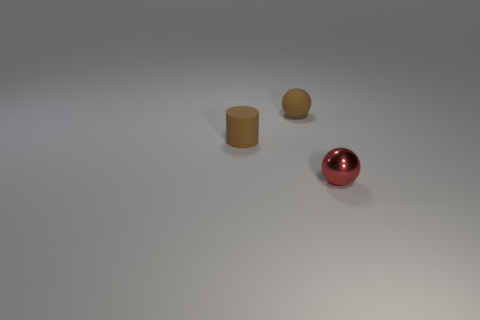Considering the surface in the image, what material might it be and can you describe the texture? The surface in the image appears to be a flat, horizontal plane with a smooth texture. The lack of any visible grain or irregularities suggests it might be made from a synthetic material or metal, possibly with a matte or a semi-gloss finish. 